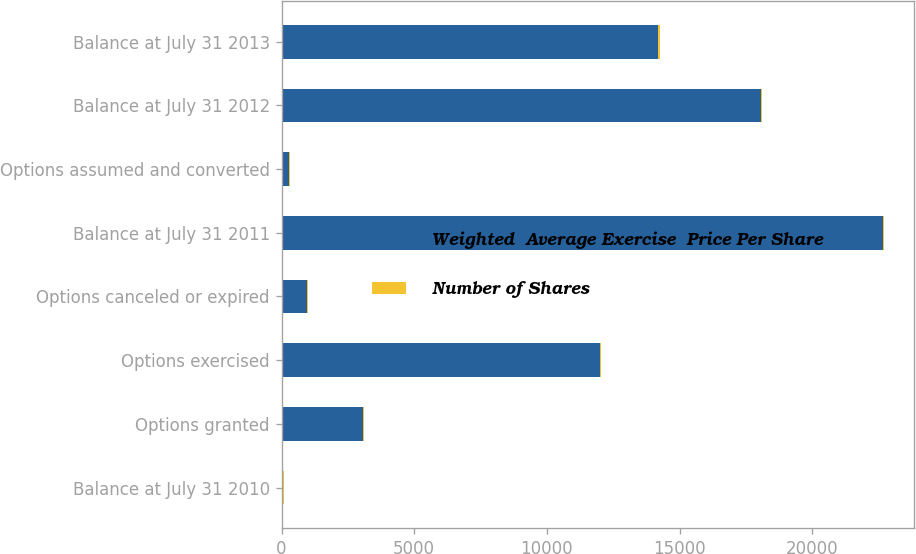Convert chart to OTSL. <chart><loc_0><loc_0><loc_500><loc_500><stacked_bar_chart><ecel><fcel>Balance at July 31 2010<fcel>Options granted<fcel>Options exercised<fcel>Options canceled or expired<fcel>Balance at July 31 2011<fcel>Options assumed and converted<fcel>Balance at July 31 2012<fcel>Balance at July 31 2013<nl><fcel>Weighted  Average Exercise  Price Per Share<fcel>54.51<fcel>3055<fcel>11997<fcel>972<fcel>22679<fcel>282<fcel>18061<fcel>14206<nl><fcel>Number of Shares<fcel>28.45<fcel>47.7<fcel>25.68<fcel>31.44<fcel>32.38<fcel>54.51<fcel>37.49<fcel>43.77<nl></chart> 